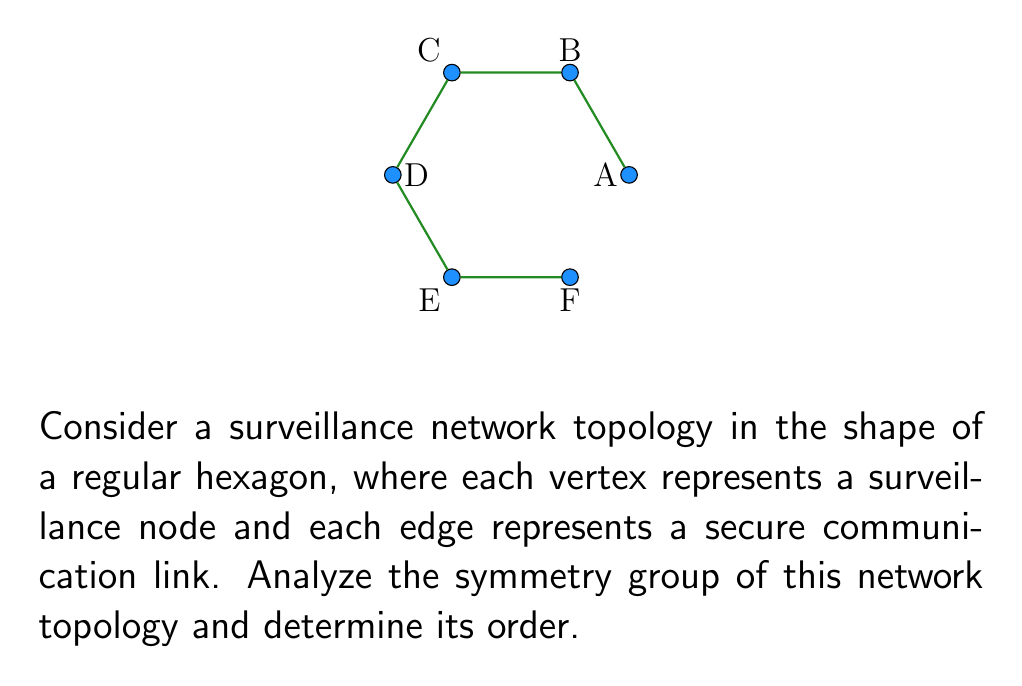Can you solve this math problem? To analyze the symmetry group of this surveillance network topology, we need to consider all the symmetries that preserve the structure of the regular hexagon:

1) Rotational symmetries:
   - Identity rotation (0°)
   - Rotations by 60°, 120°, 180°, 240°, and 300°

2) Reflection symmetries:
   - Reflections across the three diagonals of the hexagon
   - Reflections across the three lines connecting opposite vertices

Step 1: Count the rotational symmetries
There are 6 rotational symmetries (including the identity).

Step 2: Count the reflection symmetries
There are 6 reflection symmetries (3 diagonals + 3 lines connecting opposite vertices).

Step 3: Determine the symmetry group
The symmetry group of a regular hexagon is the dihedral group $D_6$.

Step 4: Calculate the order of the group
The order of $D_6$ is given by the formula:
$$ |D_n| = 2n $$
Where $n$ is the number of sides of the regular polygon.

For a hexagon, $n = 6$, so:
$$ |D_6| = 2 \cdot 6 = 12 $$

Therefore, the order of the symmetry group of this surveillance network topology is 12.
Answer: $|D_6| = 12$ 